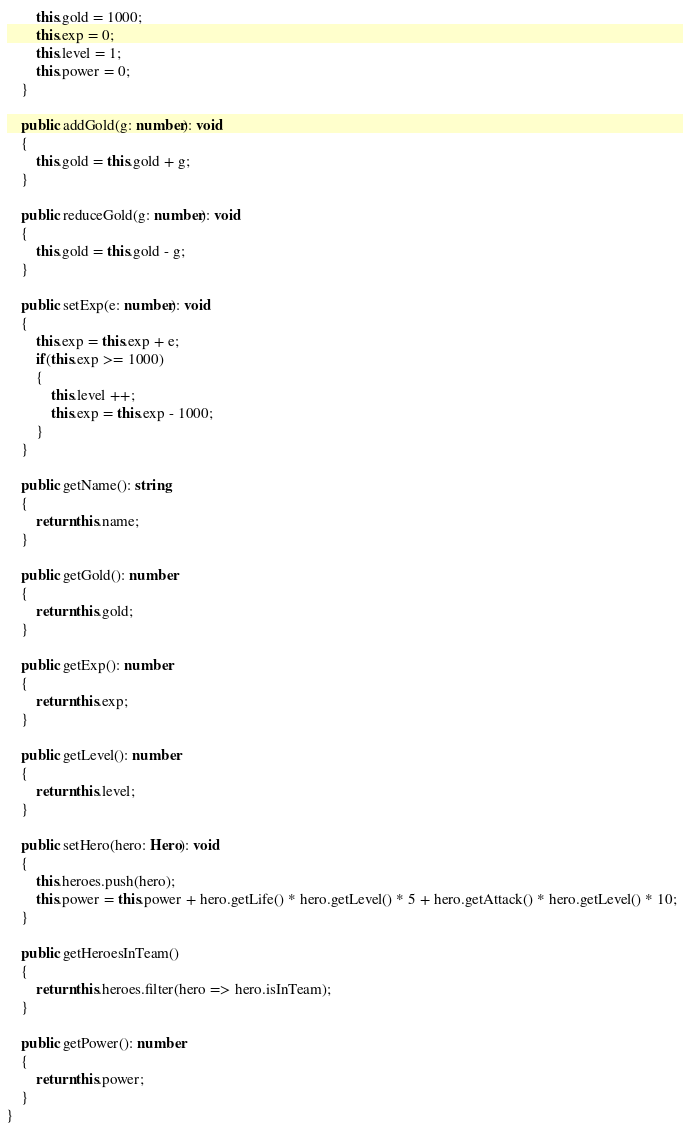<code> <loc_0><loc_0><loc_500><loc_500><_TypeScript_>        this.gold = 1000;
        this.exp = 0;
        this.level = 1;
        this.power = 0;
    }

    public addGold(g: number): void
    {
        this.gold = this.gold + g;
    }

    public reduceGold(g: number): void
    {
        this.gold = this.gold - g;
    }

    public setExp(e: number): void
    {
        this.exp = this.exp + e;
        if(this.exp >= 1000)
        {
            this.level ++;
            this.exp = this.exp - 1000;
        }
    }

    public getName(): string
    {
        return this.name;
    }

    public getGold(): number
    {
        return this.gold;
    }

    public getExp(): number
    {
        return this.exp;        
    }

    public getLevel(): number
    {
        return this.level;
    }

    public setHero(hero: Hero): void 
    {
        this.heroes.push(hero);
        this.power = this.power + hero.getLife() * hero.getLevel() * 5 + hero.getAttack() * hero.getLevel() * 10;
    }

    public getHeroesInTeam()
    {
        return this.heroes.filter(hero => hero.isInTeam);
    }

    public getPower(): number 
    {
        return this.power;
    }
}
</code> 